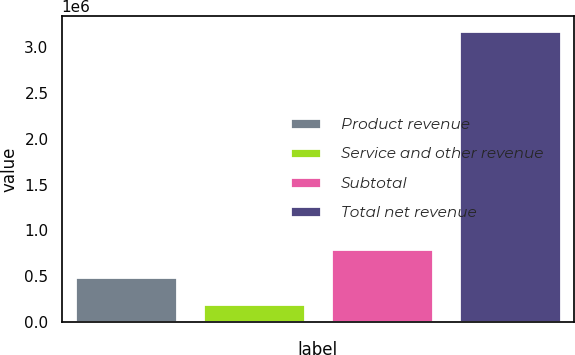Convert chart. <chart><loc_0><loc_0><loc_500><loc_500><bar_chart><fcel>Product revenue<fcel>Service and other revenue<fcel>Subtotal<fcel>Total net revenue<nl><fcel>494473<fcel>195799<fcel>793147<fcel>3.18254e+06<nl></chart> 